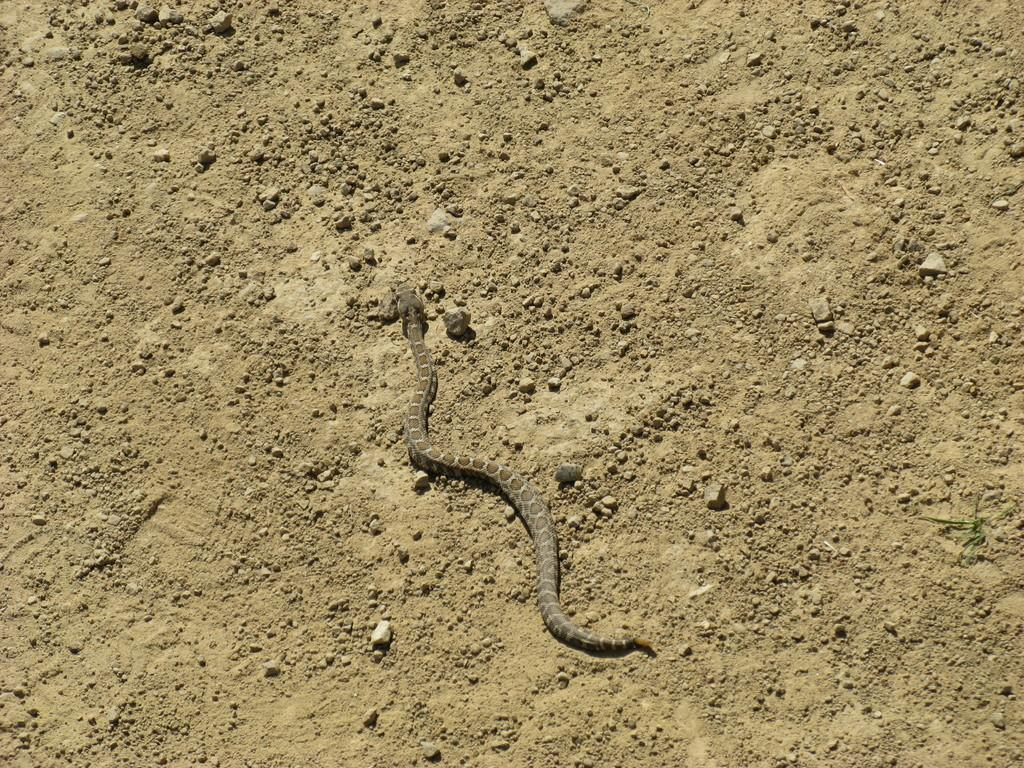What animal is present in the image? There is a snake in the image. What is the snake doing in the image? The snake is crawling on the ground. What type of terrain can be seen in the image? There are stones and mud on the ground. What color is the curtain hanging in the background of the image? There is no curtain present in the image; it only features a snake crawling on the ground with stones and mud. 